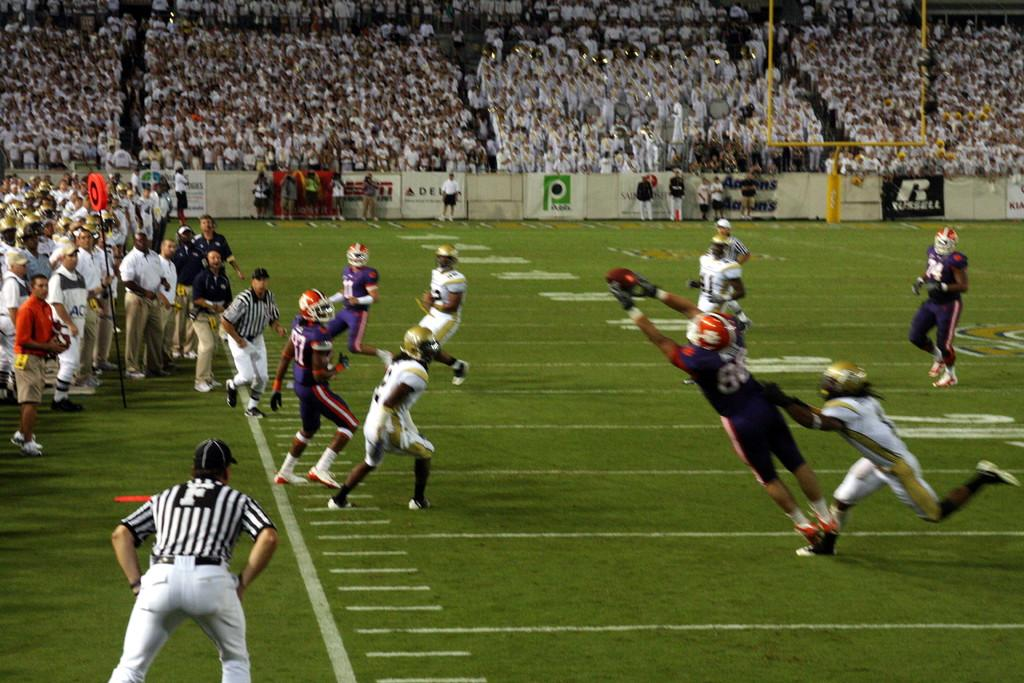What are the people in the image doing? There are people playing on the grass and people watching the match in the image. What can be seen in the background of the image? There are banners visible in the image. What type of alarm can be heard going off in the image? There is no alarm present in the image, and therefore no such sound can be heard. 